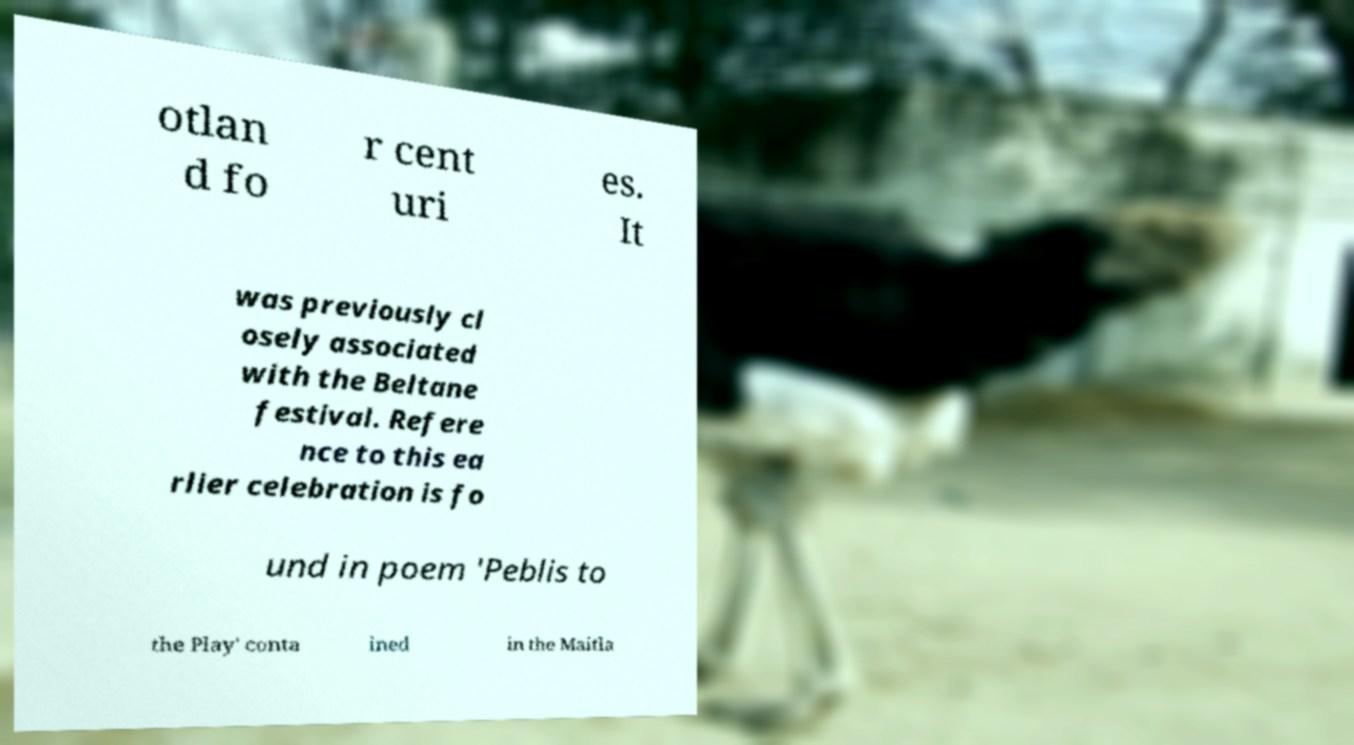There's text embedded in this image that I need extracted. Can you transcribe it verbatim? otlan d fo r cent uri es. It was previously cl osely associated with the Beltane festival. Refere nce to this ea rlier celebration is fo und in poem 'Peblis to the Play' conta ined in the Maitla 